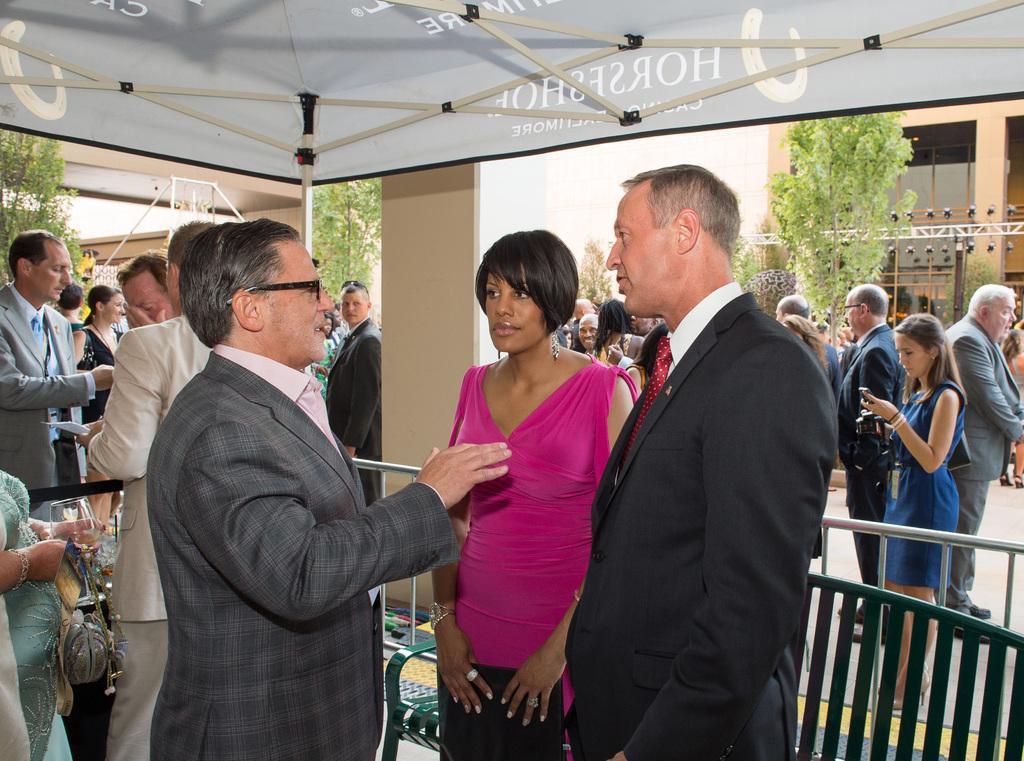Can you describe this image briefly? This picture shows few people standing and we see a man wore spectacles on his face and we see few buildings and trees and a tent and a woman standing and holding mobile in her hand and we see all the men wore coats and we see a woman holding glass in her hand. 